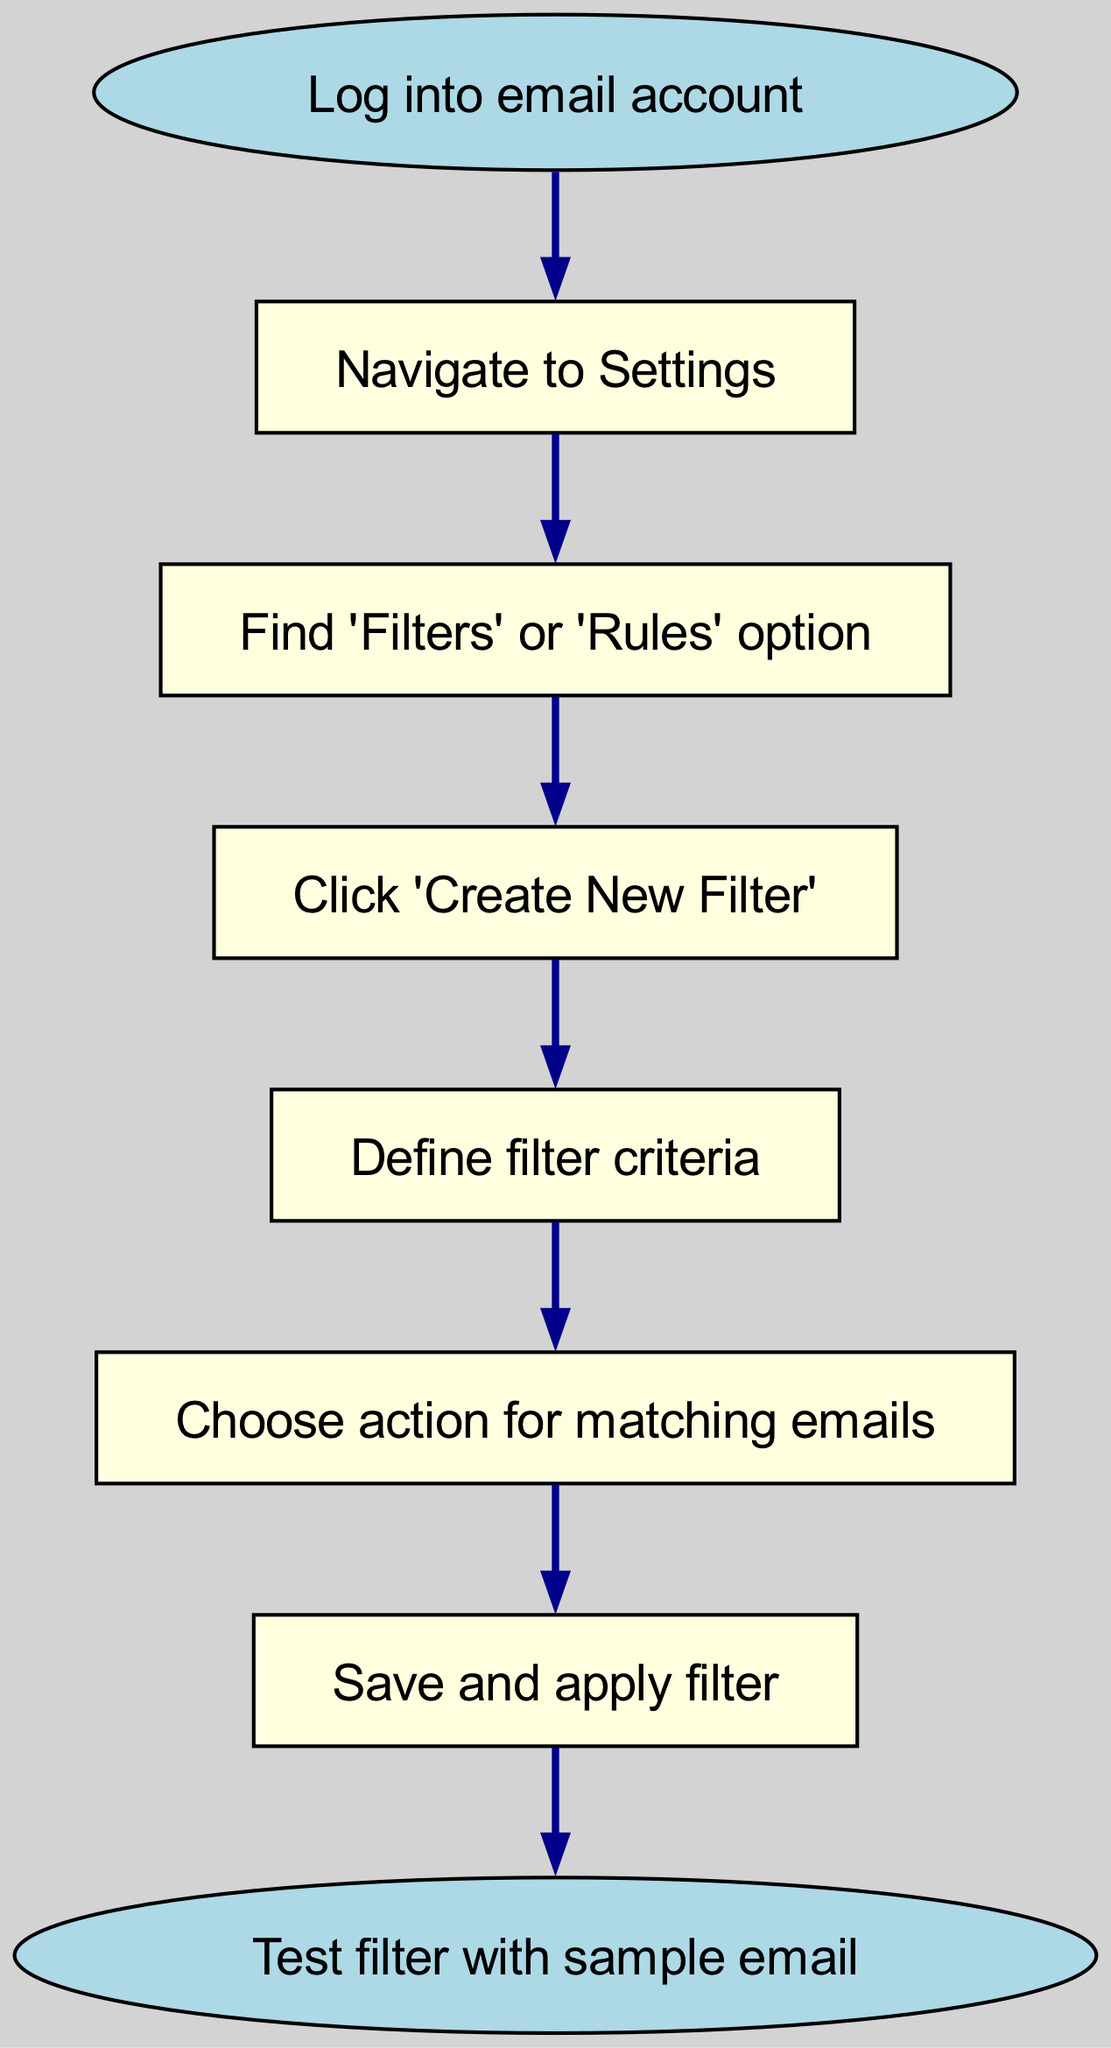What is the first step in the process? The diagram starts with the "Log into email account" node, which indicates the first action that needs to be taken to begin the process.
Answer: Log into email account How many steps are there in the entire process? By counting the unique nodes, there are a total of 7 steps listed in the diagram, from start to end.
Answer: 7 What action is taken after defining filter criteria? The next step after "Define filter criteria" is "Choose action for matching emails," indicating the sequence of steps in the filtering process.
Answer: Choose action for matching emails Which node represents the final outcome in the flow? The "Test filter with sample email" node at the end indicates the conclusion of the process flow, indicating that the filter is ready to be tested.
Answer: Test filter with sample email What is the relationship between 'Navigate to Settings' and 'Find Filters or Rules option'? 'Navigate to Settings' is directly connected to 'Find Filters or Rules option,' indicating that after navigating to settings, the next step is to find the filters option.
Answer: Directly connected Which step involves creating a new filter? The step that specifically mentions creating a new filter is "Click 'Create New Filter,'" which is an essential part of establishing email filters.
Answer: Click 'Create New Filter' What step comes immediately after saving and applying the filter? The step that follows "Save and apply filter" is "Test filter with sample email," demonstrating that testing comes after configuring the filter.
Answer: Test filter with sample email How many connections are there in the diagram? Observing the diagram reveals 6 connections between the 7 nodes, illustrating the flow from the starting point to the end.
Answer: 6 What action is taken before testing the filter? The action taken before testing the filter is "Save and apply filter," which must be done to ensure that the filter is active for testing.
Answer: Save and apply filter 